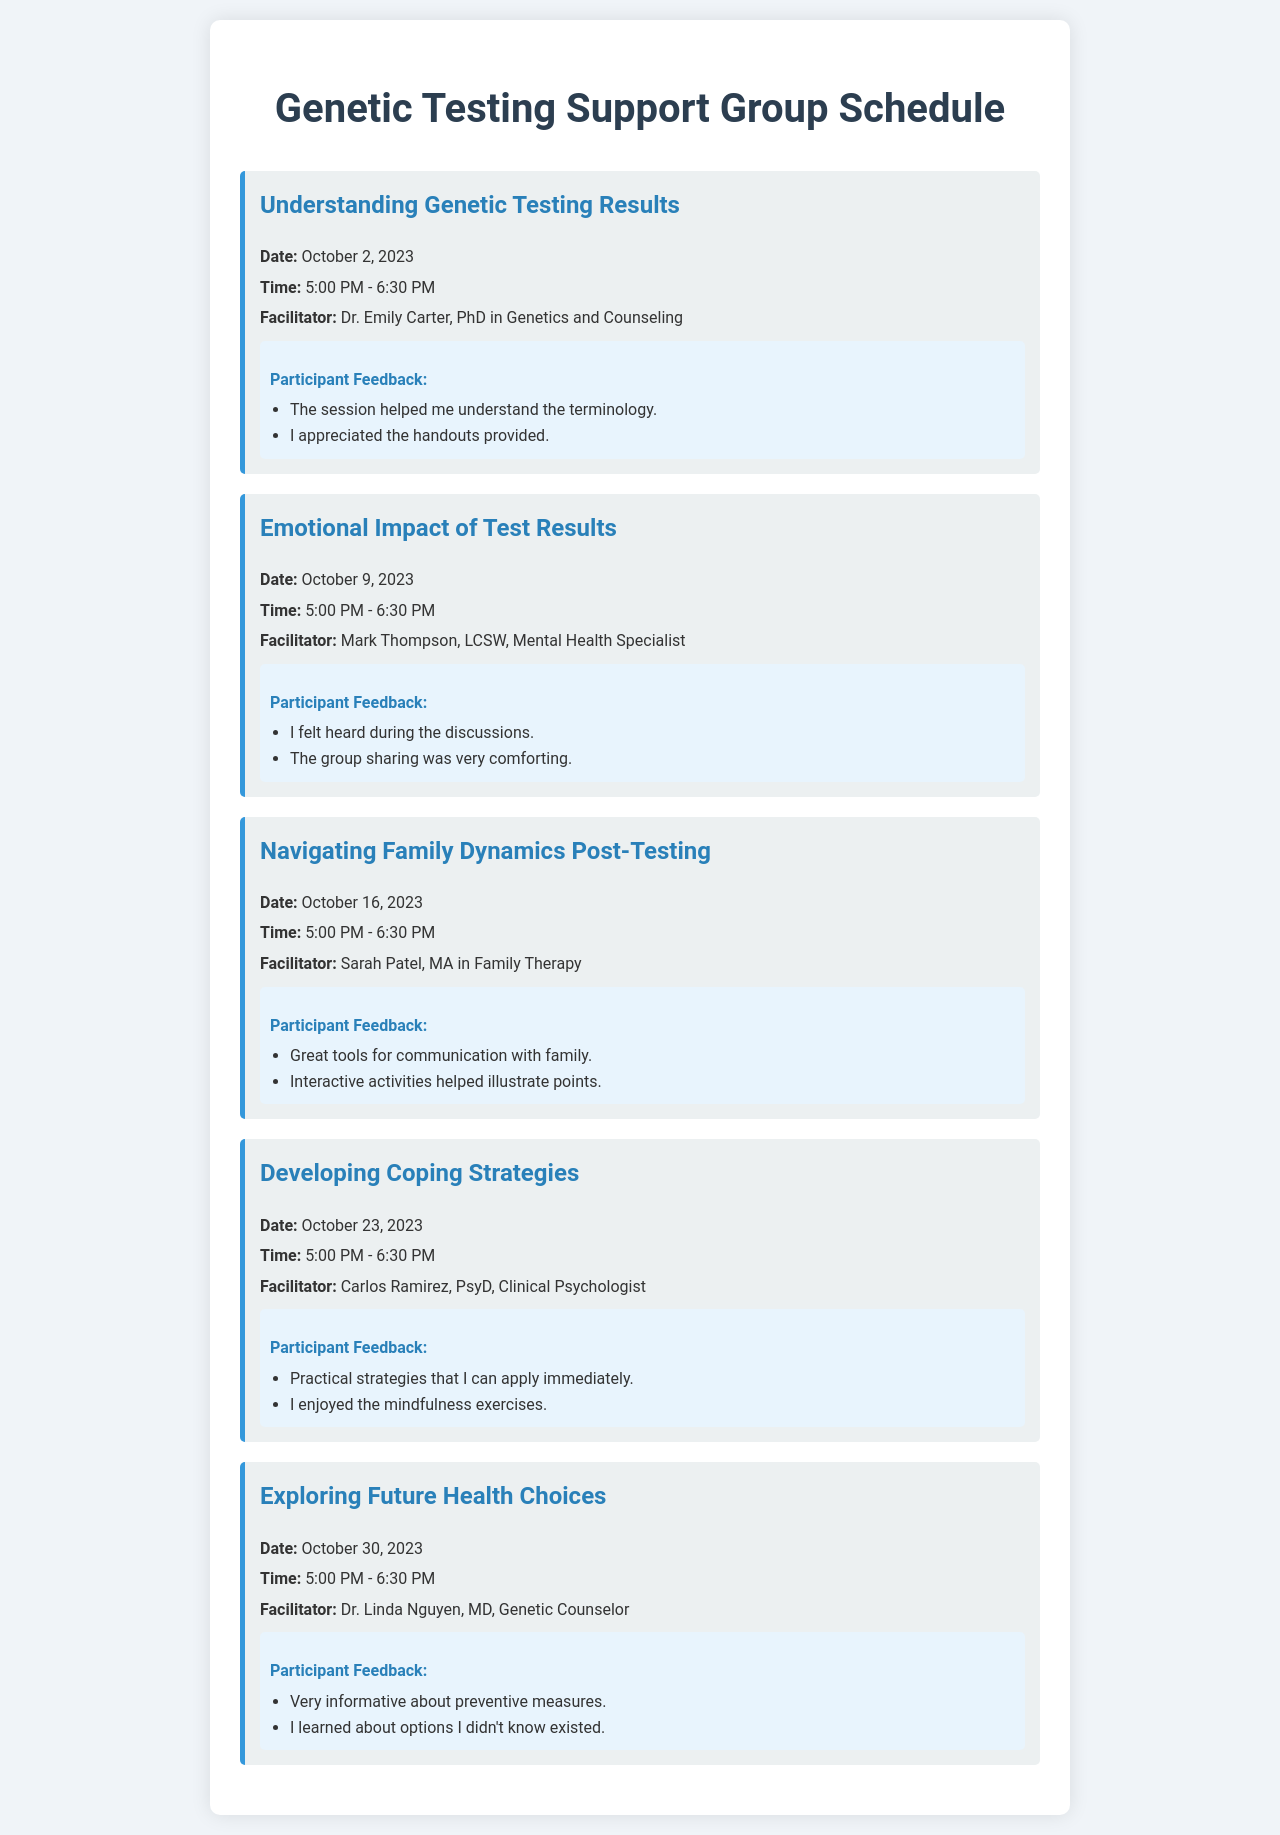What is the title of the support group schedule? The title of the document is shown prominently at the top of the schedule.
Answer: Genetic Testing Support Group Schedule Who is the facilitator for the session on October 9, 2023? Each session lists the facilitator’s name, specifically for the session on emotional impact of test results.
Answer: Mark Thompson What is the date of the session on developing coping strategies? Each session is accompanied by its specific date, particularly for coping strategies.
Answer: October 23, 2023 How long does each session last? The duration for each session is mentioned in the time format provided in the document.
Answer: 1 hour 30 minutes What was a piece of feedback for the session on understanding genetic testing results? The feedback section captures participant comments specifically for that session.
Answer: The session helped me understand the terminology Which session discusses family dynamics post-testing? The document explicitly states the topic of each session, allowing for direct identification.
Answer: Navigating Family Dynamics Post-Testing What time does the session on exploring future health choices start? The start time is listed in each session, particularly for future health choices.
Answer: 5:00 PM Who facilitates the session on emotional impact of test results? The facilitator's name is provided for each session individually, particularly for emotional support.
Answer: Mark Thompson What are the two key topics discussed in the session on developing coping strategies? Participant feedback gives insight into the topics discussed in the session.
Answer: Practical strategies and mindfulness exercises 